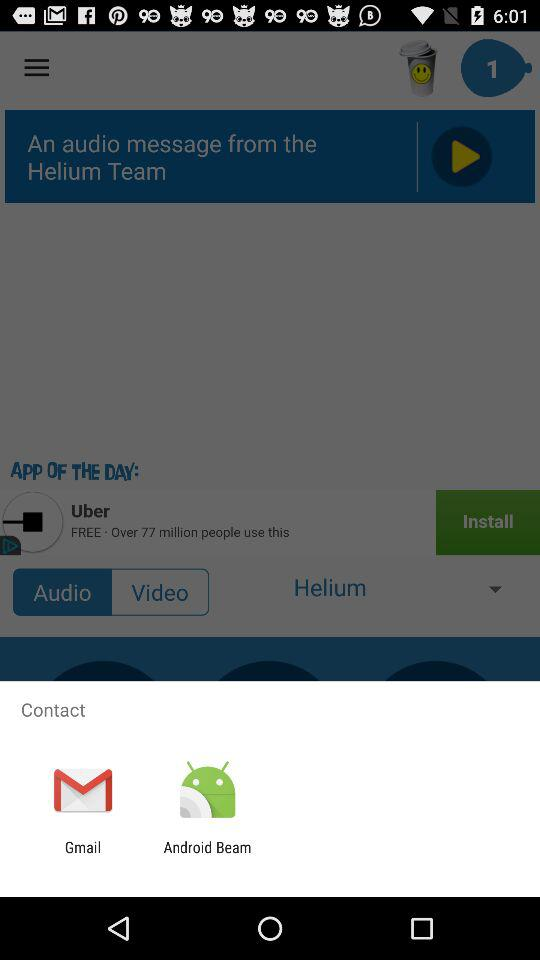Which application can I use to make contact? You can use the applications "Gmail" and "Android Beam". 